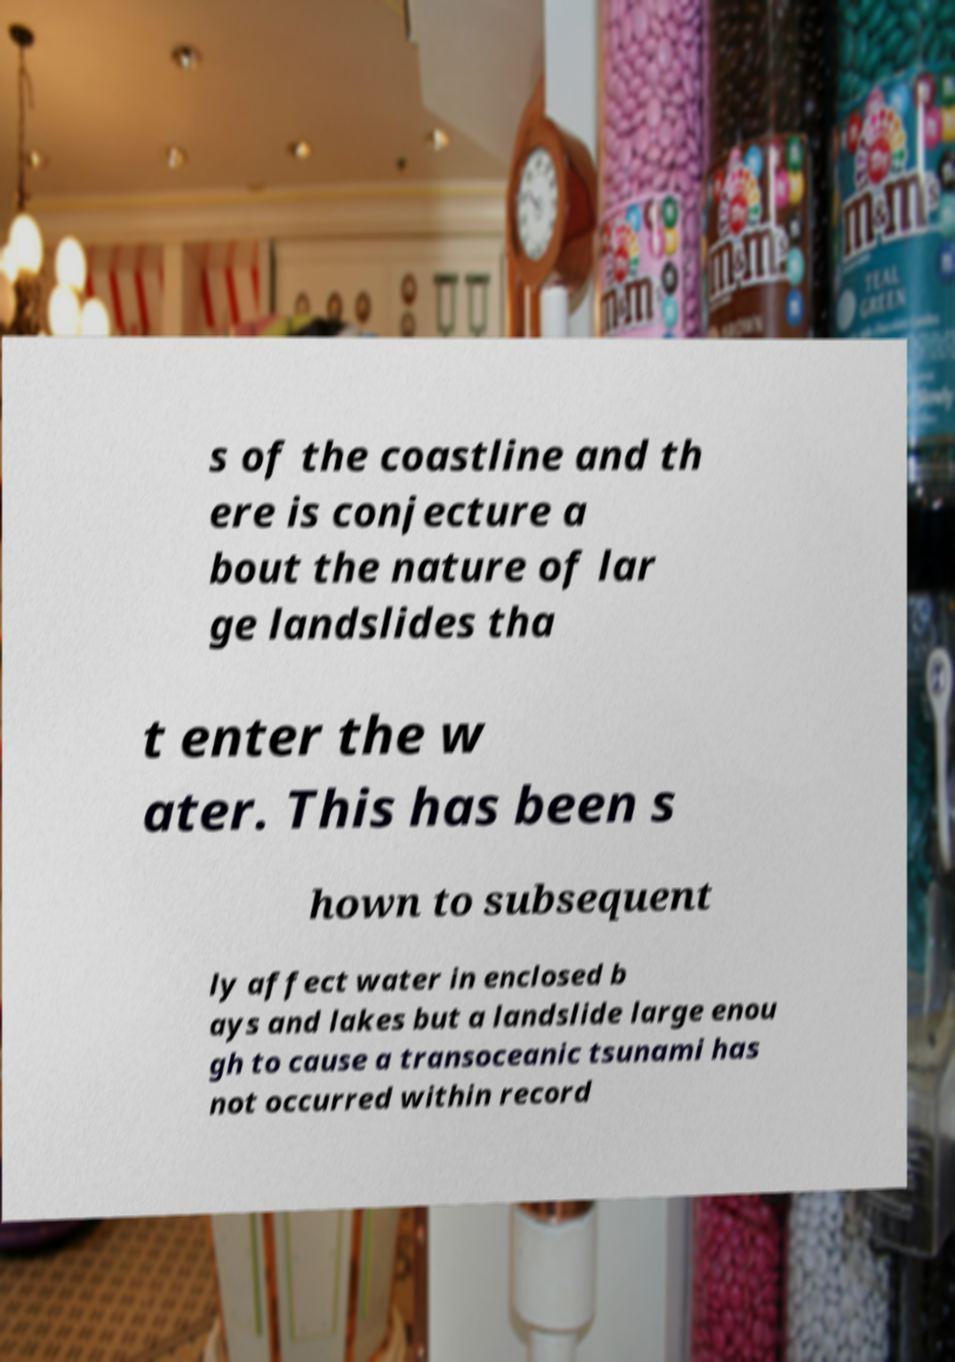Please read and relay the text visible in this image. What does it say? s of the coastline and th ere is conjecture a bout the nature of lar ge landslides tha t enter the w ater. This has been s hown to subsequent ly affect water in enclosed b ays and lakes but a landslide large enou gh to cause a transoceanic tsunami has not occurred within record 